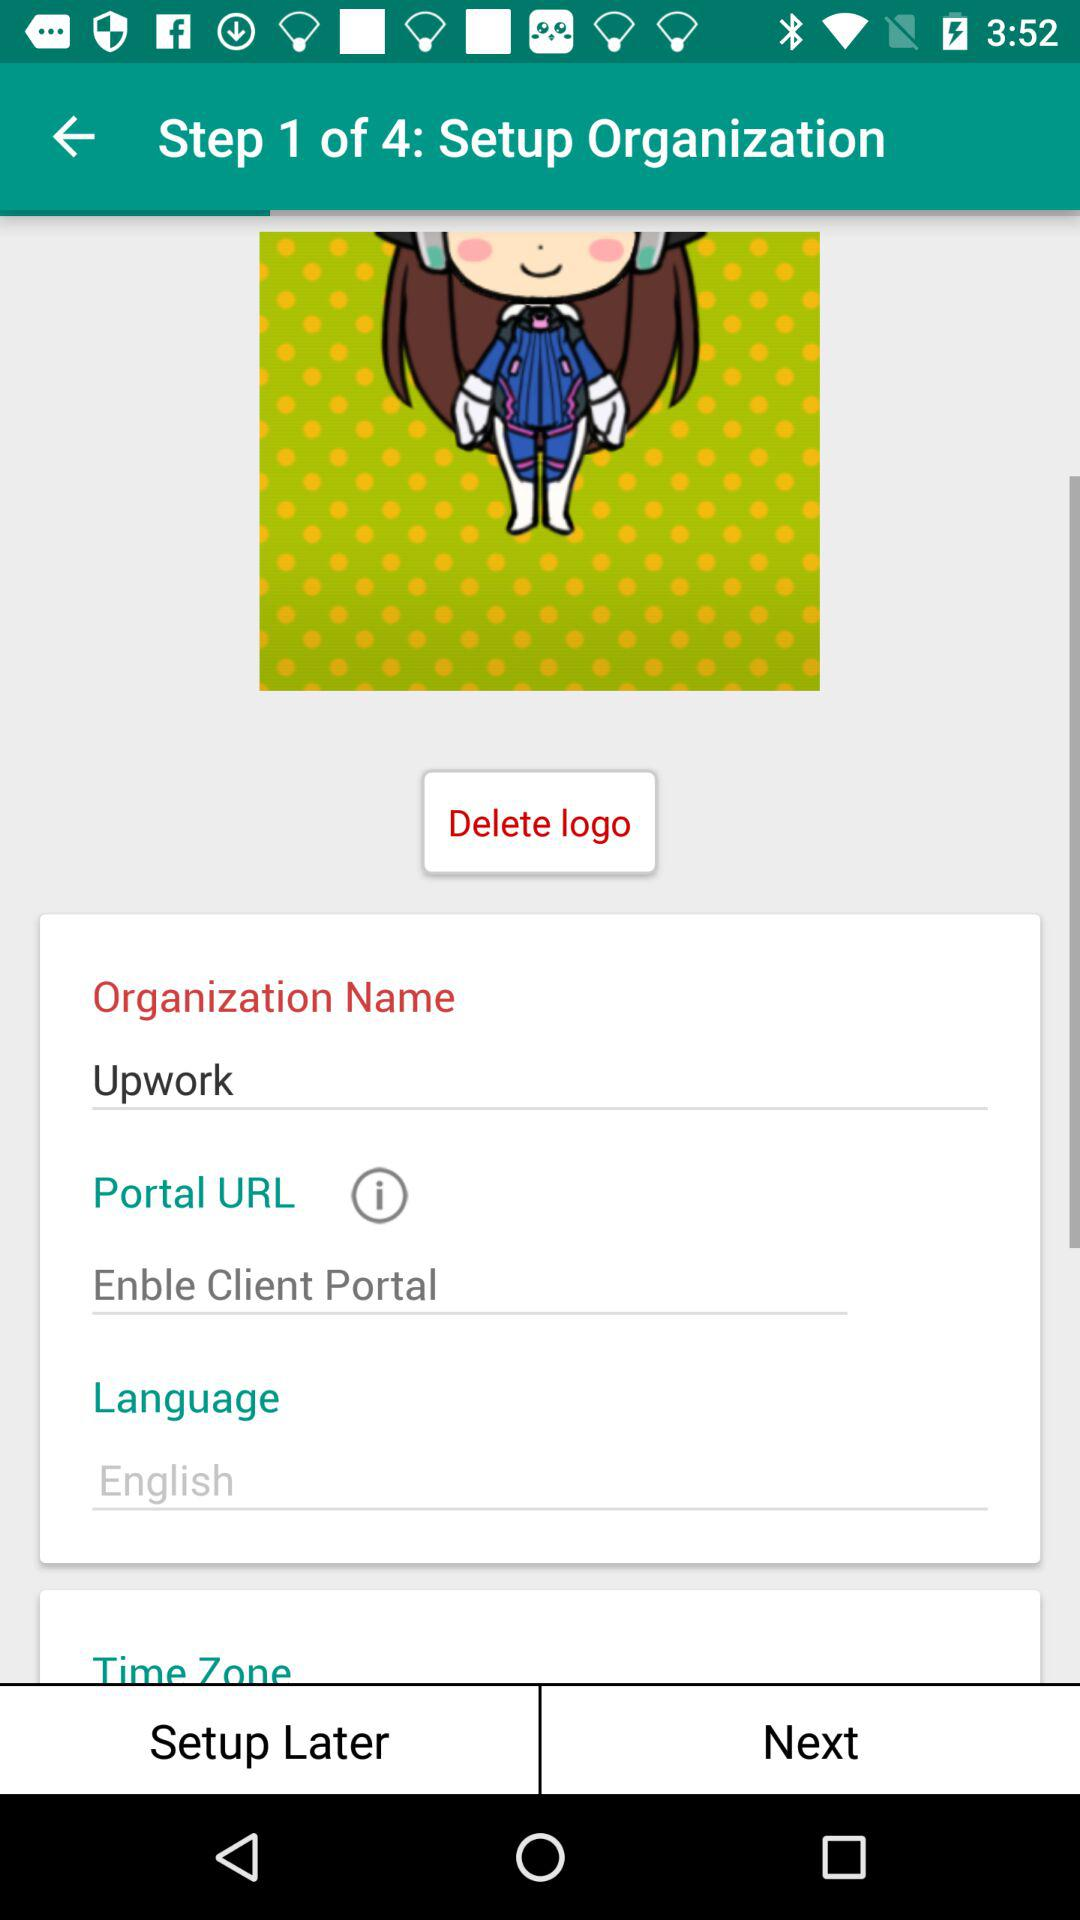What is the status of the "Portal URL"? The status is "Enble Client Portal". 